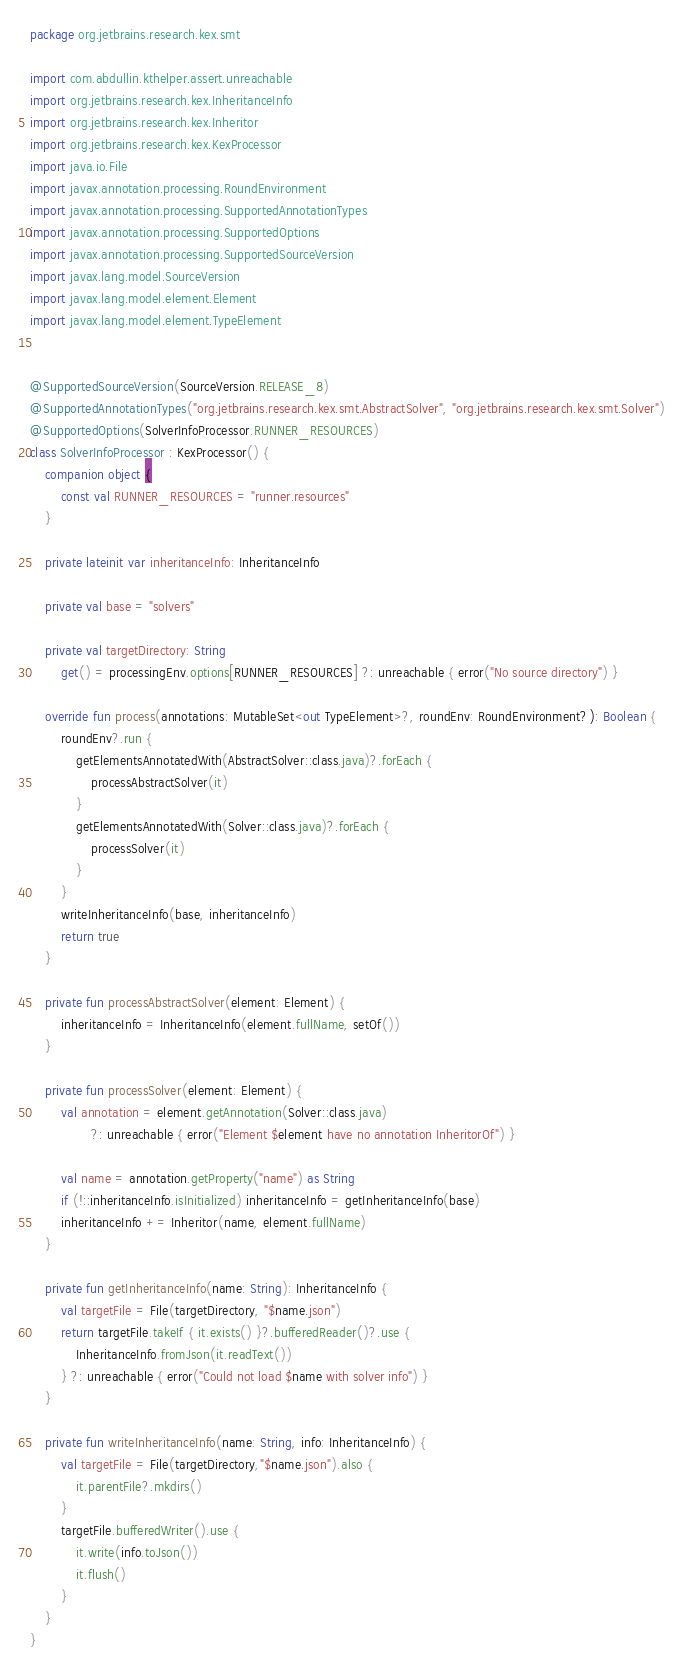Convert code to text. <code><loc_0><loc_0><loc_500><loc_500><_Kotlin_>package org.jetbrains.research.kex.smt

import com.abdullin.kthelper.assert.unreachable
import org.jetbrains.research.kex.InheritanceInfo
import org.jetbrains.research.kex.Inheritor
import org.jetbrains.research.kex.KexProcessor
import java.io.File
import javax.annotation.processing.RoundEnvironment
import javax.annotation.processing.SupportedAnnotationTypes
import javax.annotation.processing.SupportedOptions
import javax.annotation.processing.SupportedSourceVersion
import javax.lang.model.SourceVersion
import javax.lang.model.element.Element
import javax.lang.model.element.TypeElement


@SupportedSourceVersion(SourceVersion.RELEASE_8)
@SupportedAnnotationTypes("org.jetbrains.research.kex.smt.AbstractSolver", "org.jetbrains.research.kex.smt.Solver")
@SupportedOptions(SolverInfoProcessor.RUNNER_RESOURCES)
class SolverInfoProcessor : KexProcessor() {
    companion object {
        const val RUNNER_RESOURCES = "runner.resources"
    }

    private lateinit var inheritanceInfo: InheritanceInfo

    private val base = "solvers"

    private val targetDirectory: String
        get() = processingEnv.options[RUNNER_RESOURCES] ?: unreachable { error("No source directory") }

    override fun process(annotations: MutableSet<out TypeElement>?, roundEnv: RoundEnvironment?): Boolean {
        roundEnv?.run {
            getElementsAnnotatedWith(AbstractSolver::class.java)?.forEach {
                processAbstractSolver(it)
            }
            getElementsAnnotatedWith(Solver::class.java)?.forEach {
                processSolver(it)
            }
        }
        writeInheritanceInfo(base, inheritanceInfo)
        return true
    }

    private fun processAbstractSolver(element: Element) {
        inheritanceInfo = InheritanceInfo(element.fullName, setOf())
    }

    private fun processSolver(element: Element) {
        val annotation = element.getAnnotation(Solver::class.java)
                ?: unreachable { error("Element $element have no annotation InheritorOf") }

        val name = annotation.getProperty("name") as String
        if (!::inheritanceInfo.isInitialized) inheritanceInfo = getInheritanceInfo(base)
        inheritanceInfo += Inheritor(name, element.fullName)
    }

    private fun getInheritanceInfo(name: String): InheritanceInfo {
        val targetFile = File(targetDirectory, "$name.json")
        return targetFile.takeIf { it.exists() }?.bufferedReader()?.use {
            InheritanceInfo.fromJson(it.readText())
        } ?: unreachable { error("Could not load $name with solver info") }
    }

    private fun writeInheritanceInfo(name: String, info: InheritanceInfo) {
        val targetFile = File(targetDirectory,"$name.json").also {
            it.parentFile?.mkdirs()
        }
        targetFile.bufferedWriter().use {
            it.write(info.toJson())
            it.flush()
        }
    }
}</code> 